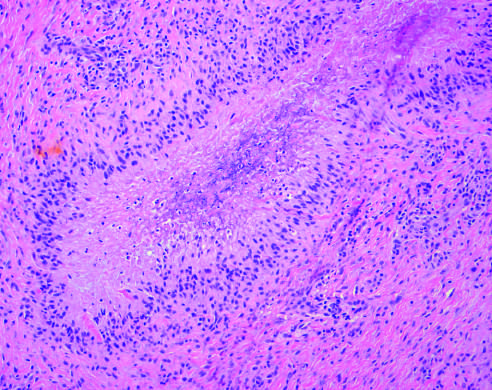what is rheumatoid nodule composed of?
Answer the question using a single word or phrase. Central necrosis 